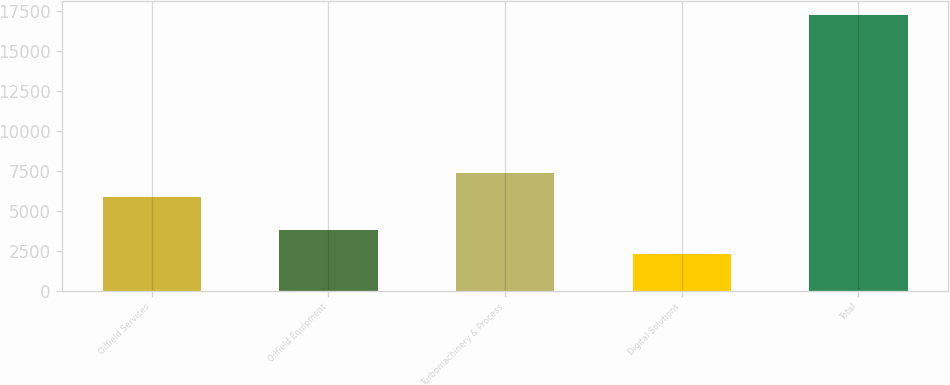Convert chart. <chart><loc_0><loc_0><loc_500><loc_500><bar_chart><fcel>Oilfield Services<fcel>Oilfield Equipment<fcel>Turbomachinery & Process<fcel>Digital Solutions<fcel>Total<nl><fcel>5851<fcel>3804<fcel>7346<fcel>2309<fcel>17259<nl></chart> 